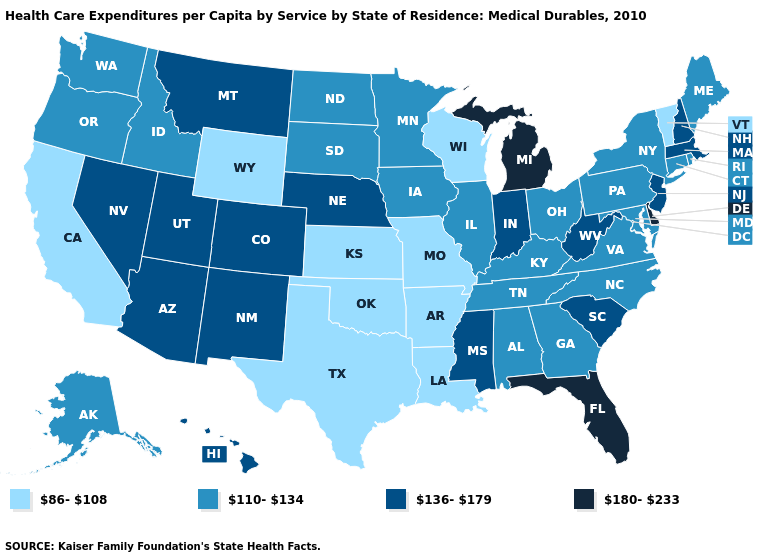Which states have the lowest value in the USA?
Concise answer only. Arkansas, California, Kansas, Louisiana, Missouri, Oklahoma, Texas, Vermont, Wisconsin, Wyoming. What is the highest value in the USA?
Give a very brief answer. 180-233. Name the states that have a value in the range 180-233?
Give a very brief answer. Delaware, Florida, Michigan. How many symbols are there in the legend?
Short answer required. 4. What is the value of Arkansas?
Answer briefly. 86-108. Name the states that have a value in the range 136-179?
Be succinct. Arizona, Colorado, Hawaii, Indiana, Massachusetts, Mississippi, Montana, Nebraska, Nevada, New Hampshire, New Jersey, New Mexico, South Carolina, Utah, West Virginia. What is the highest value in states that border Colorado?
Keep it brief. 136-179. Name the states that have a value in the range 86-108?
Quick response, please. Arkansas, California, Kansas, Louisiana, Missouri, Oklahoma, Texas, Vermont, Wisconsin, Wyoming. What is the value of Wyoming?
Keep it brief. 86-108. Name the states that have a value in the range 86-108?
Give a very brief answer. Arkansas, California, Kansas, Louisiana, Missouri, Oklahoma, Texas, Vermont, Wisconsin, Wyoming. What is the value of Iowa?
Write a very short answer. 110-134. What is the value of Hawaii?
Write a very short answer. 136-179. What is the value of Missouri?
Quick response, please. 86-108. Is the legend a continuous bar?
Write a very short answer. No. Name the states that have a value in the range 180-233?
Short answer required. Delaware, Florida, Michigan. 